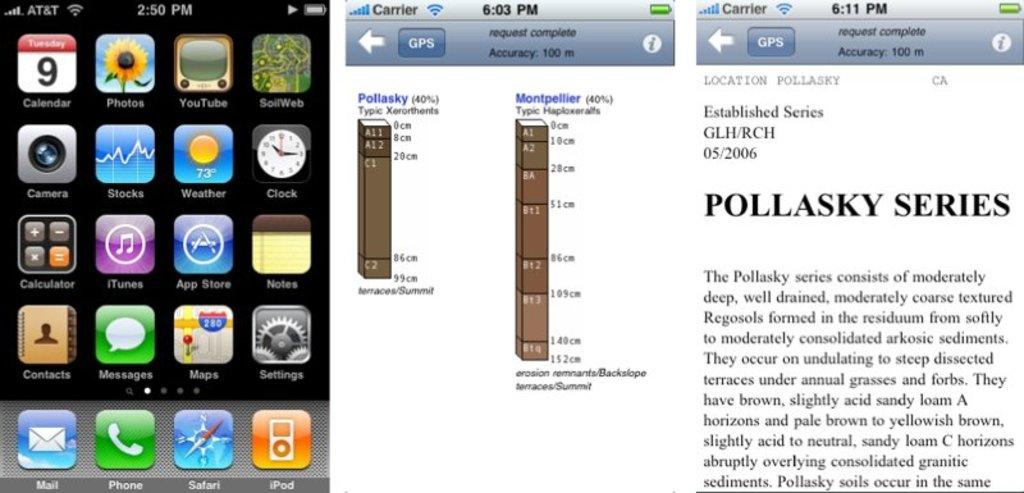<image>
Present a compact description of the photo's key features. A group of icons next to a display explaining something called Pollasky Series. 